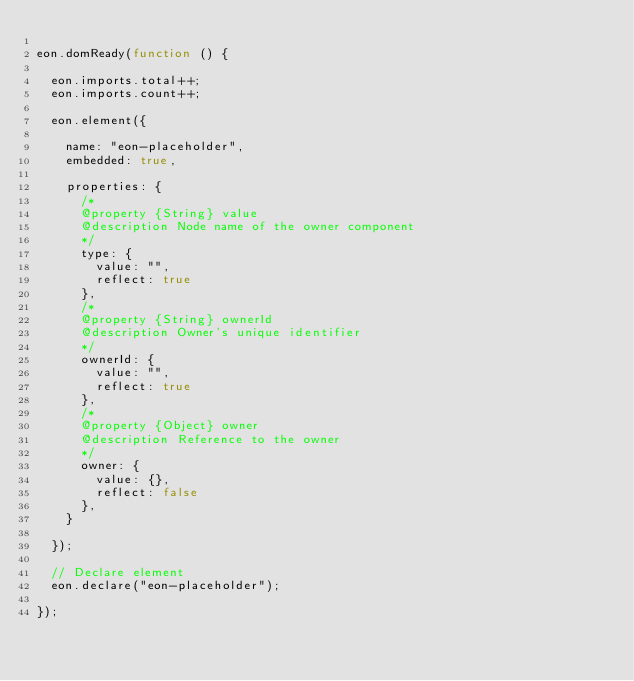Convert code to text. <code><loc_0><loc_0><loc_500><loc_500><_JavaScript_>
eon.domReady(function () {

  eon.imports.total++;
  eon.imports.count++;

  eon.element({

    name: "eon-placeholder",
    embedded: true,

    properties: {
      /*
      @property {String} value
      @description Node name of the owner component
      */
      type: {
        value: "",
        reflect: true
      },
      /*
      @property {String} ownerId
      @description Owner's unique identifier
      */
      ownerId: {
        value: "",
        reflect: true
      },
      /*
      @property {Object} owner
      @description Reference to the owner
      */
      owner: {
        value: {},
        reflect: false
      },
    }

  });

  // Declare element
  eon.declare("eon-placeholder");

});
</code> 